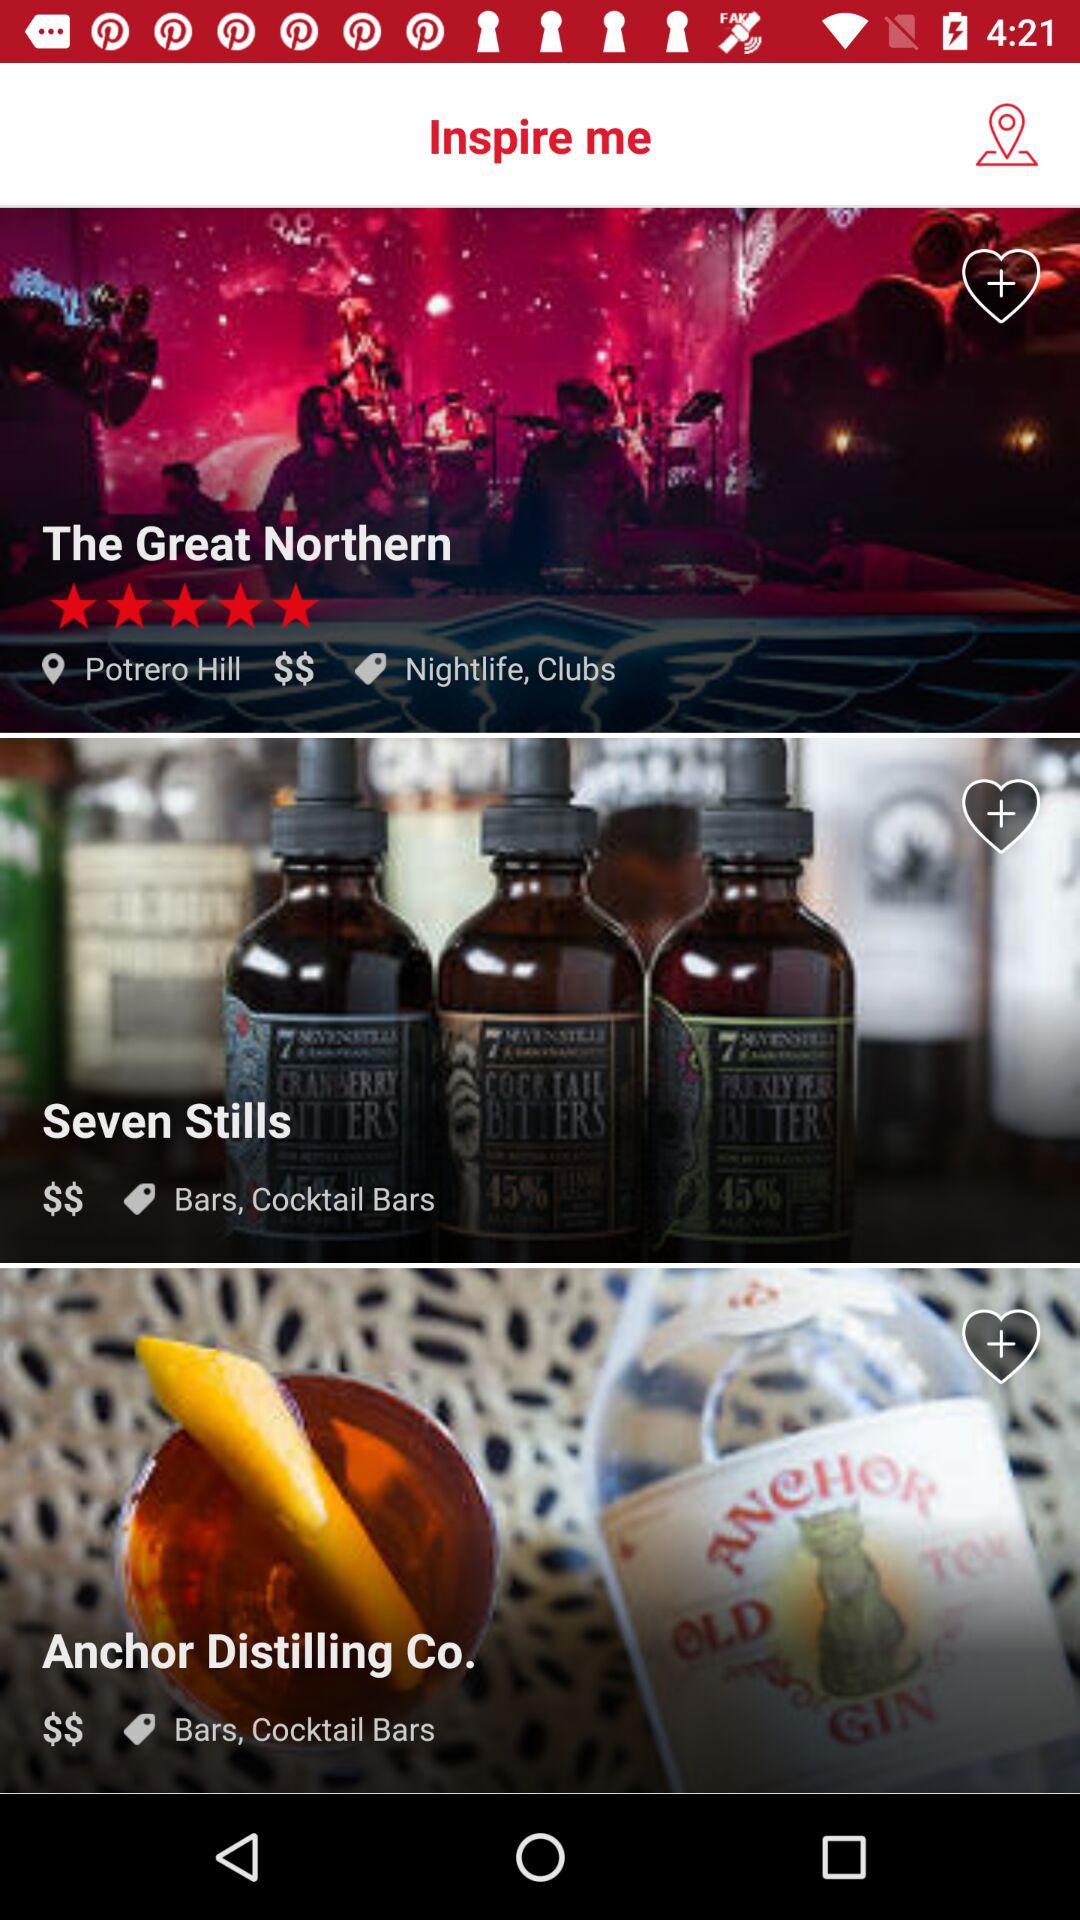How many stars are given to "The Great Northern"? The stars given to "The Great Northern" are 5. 